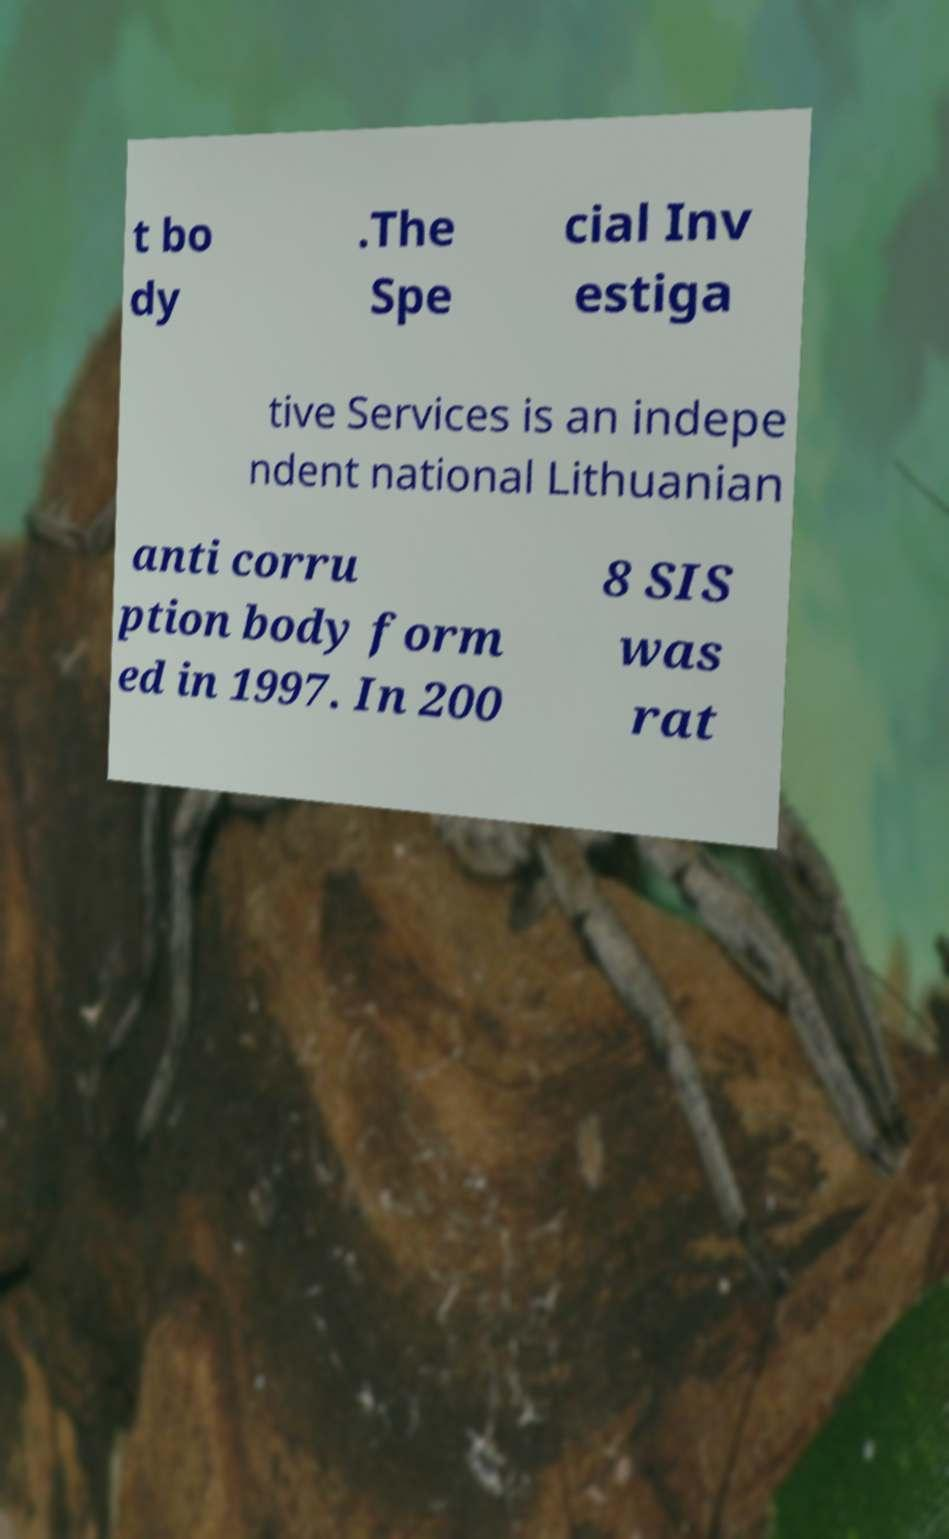Can you accurately transcribe the text from the provided image for me? t bo dy .The Spe cial Inv estiga tive Services is an indepe ndent national Lithuanian anti corru ption body form ed in 1997. In 200 8 SIS was rat 